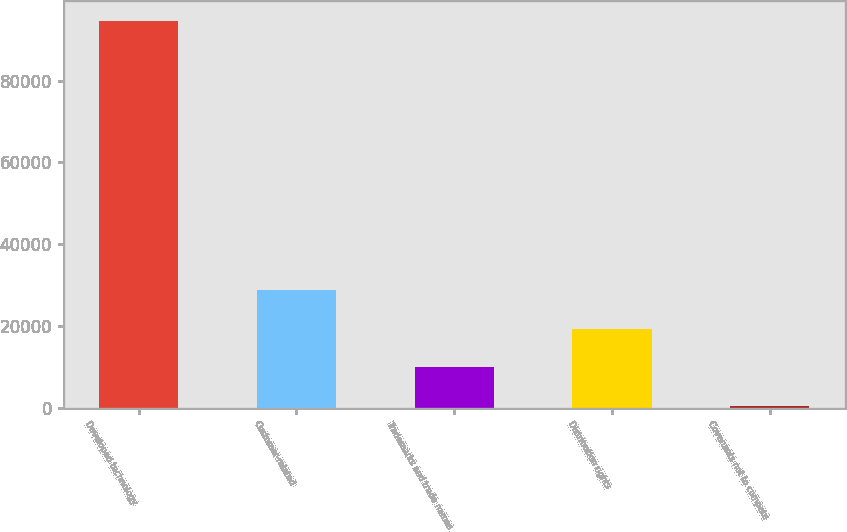Convert chart to OTSL. <chart><loc_0><loc_0><loc_500><loc_500><bar_chart><fcel>Developed technology<fcel>Customer-related<fcel>Trademarks and trade names<fcel>Distribution rights<fcel>Covenants not to compete<nl><fcel>94681<fcel>28684.3<fcel>9828.1<fcel>19256.2<fcel>400<nl></chart> 